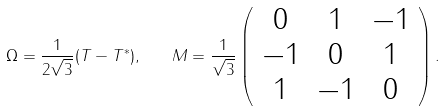Convert formula to latex. <formula><loc_0><loc_0><loc_500><loc_500>\Omega = \frac { 1 } { 2 \sqrt { 3 } } ( T - T ^ { \ast } ) , \quad M = \frac { 1 } { \sqrt { 3 } } \left ( \begin{array} { c c c } 0 & 1 & - 1 \\ - 1 & 0 & 1 \\ 1 & - 1 & 0 \end{array} \right ) .</formula> 